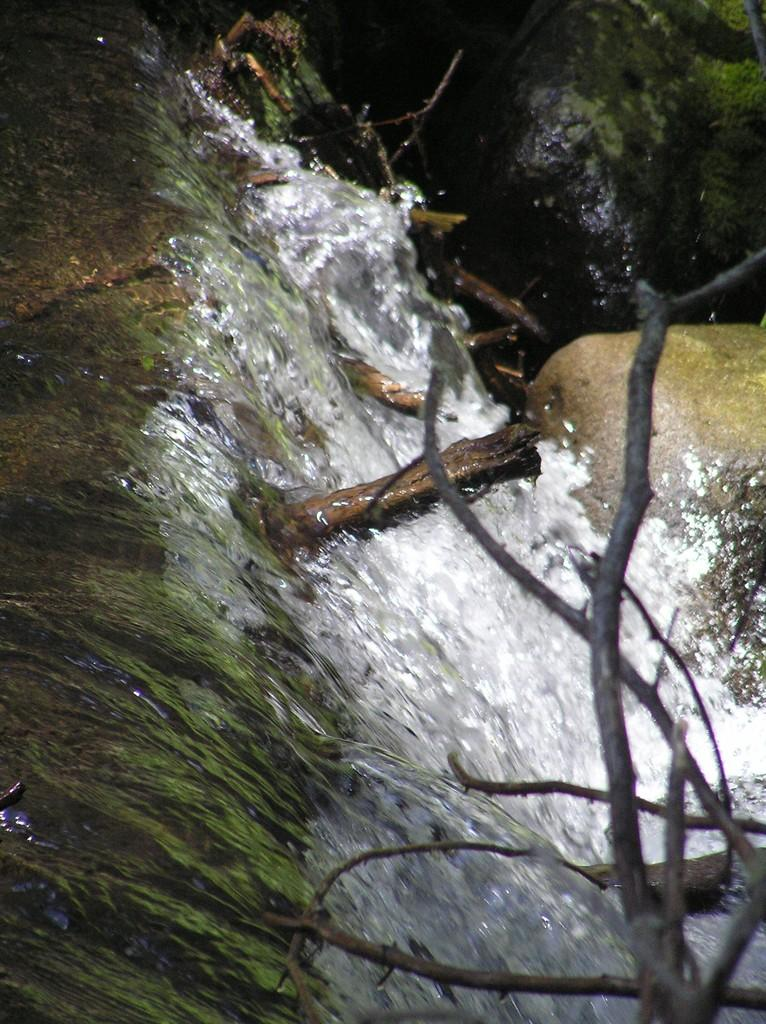What is happening in the image? There is water flowing in the image. What is the water flowing over? The water is flowing over stones. Are there any objects visible at the bottom right of the image? Yes, there are sticks at the bottom right of the image. What type of rice can be seen growing in the image? There is no rice present in the image; it features water flowing over stones and sticks at the bottom right. Is there a gun visible in the image? No, there is no gun present in the image. 